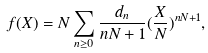Convert formula to latex. <formula><loc_0><loc_0><loc_500><loc_500>f ( X ) = N \sum _ { n \geq 0 } \frac { d _ { n } } { n N + 1 } ( \frac { X } { N } ) ^ { n N + 1 } ,</formula> 